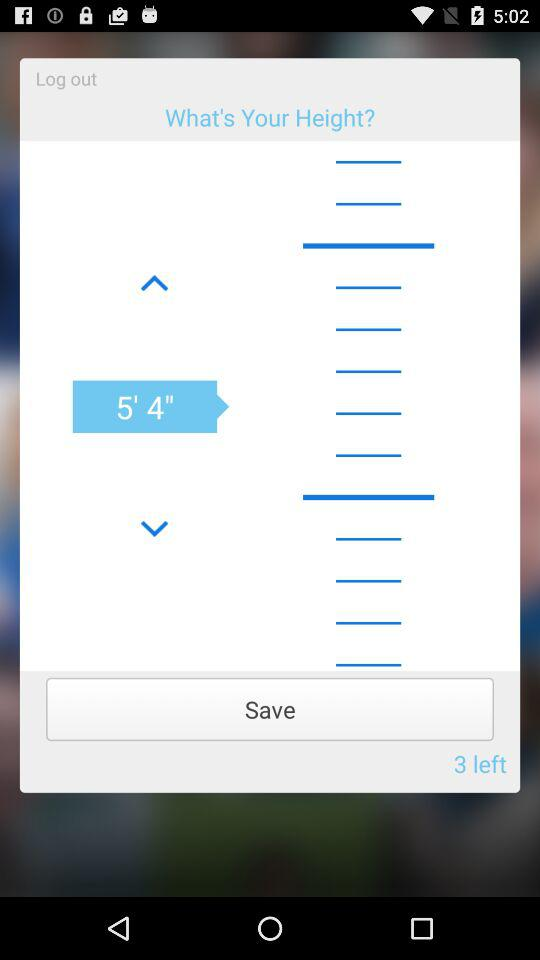How much is the weight?
When the provided information is insufficient, respond with <no answer>. <no answer> 